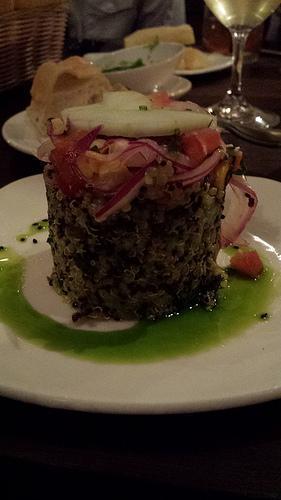How many pieces of fruit are on the plate?
Give a very brief answer. 1. 